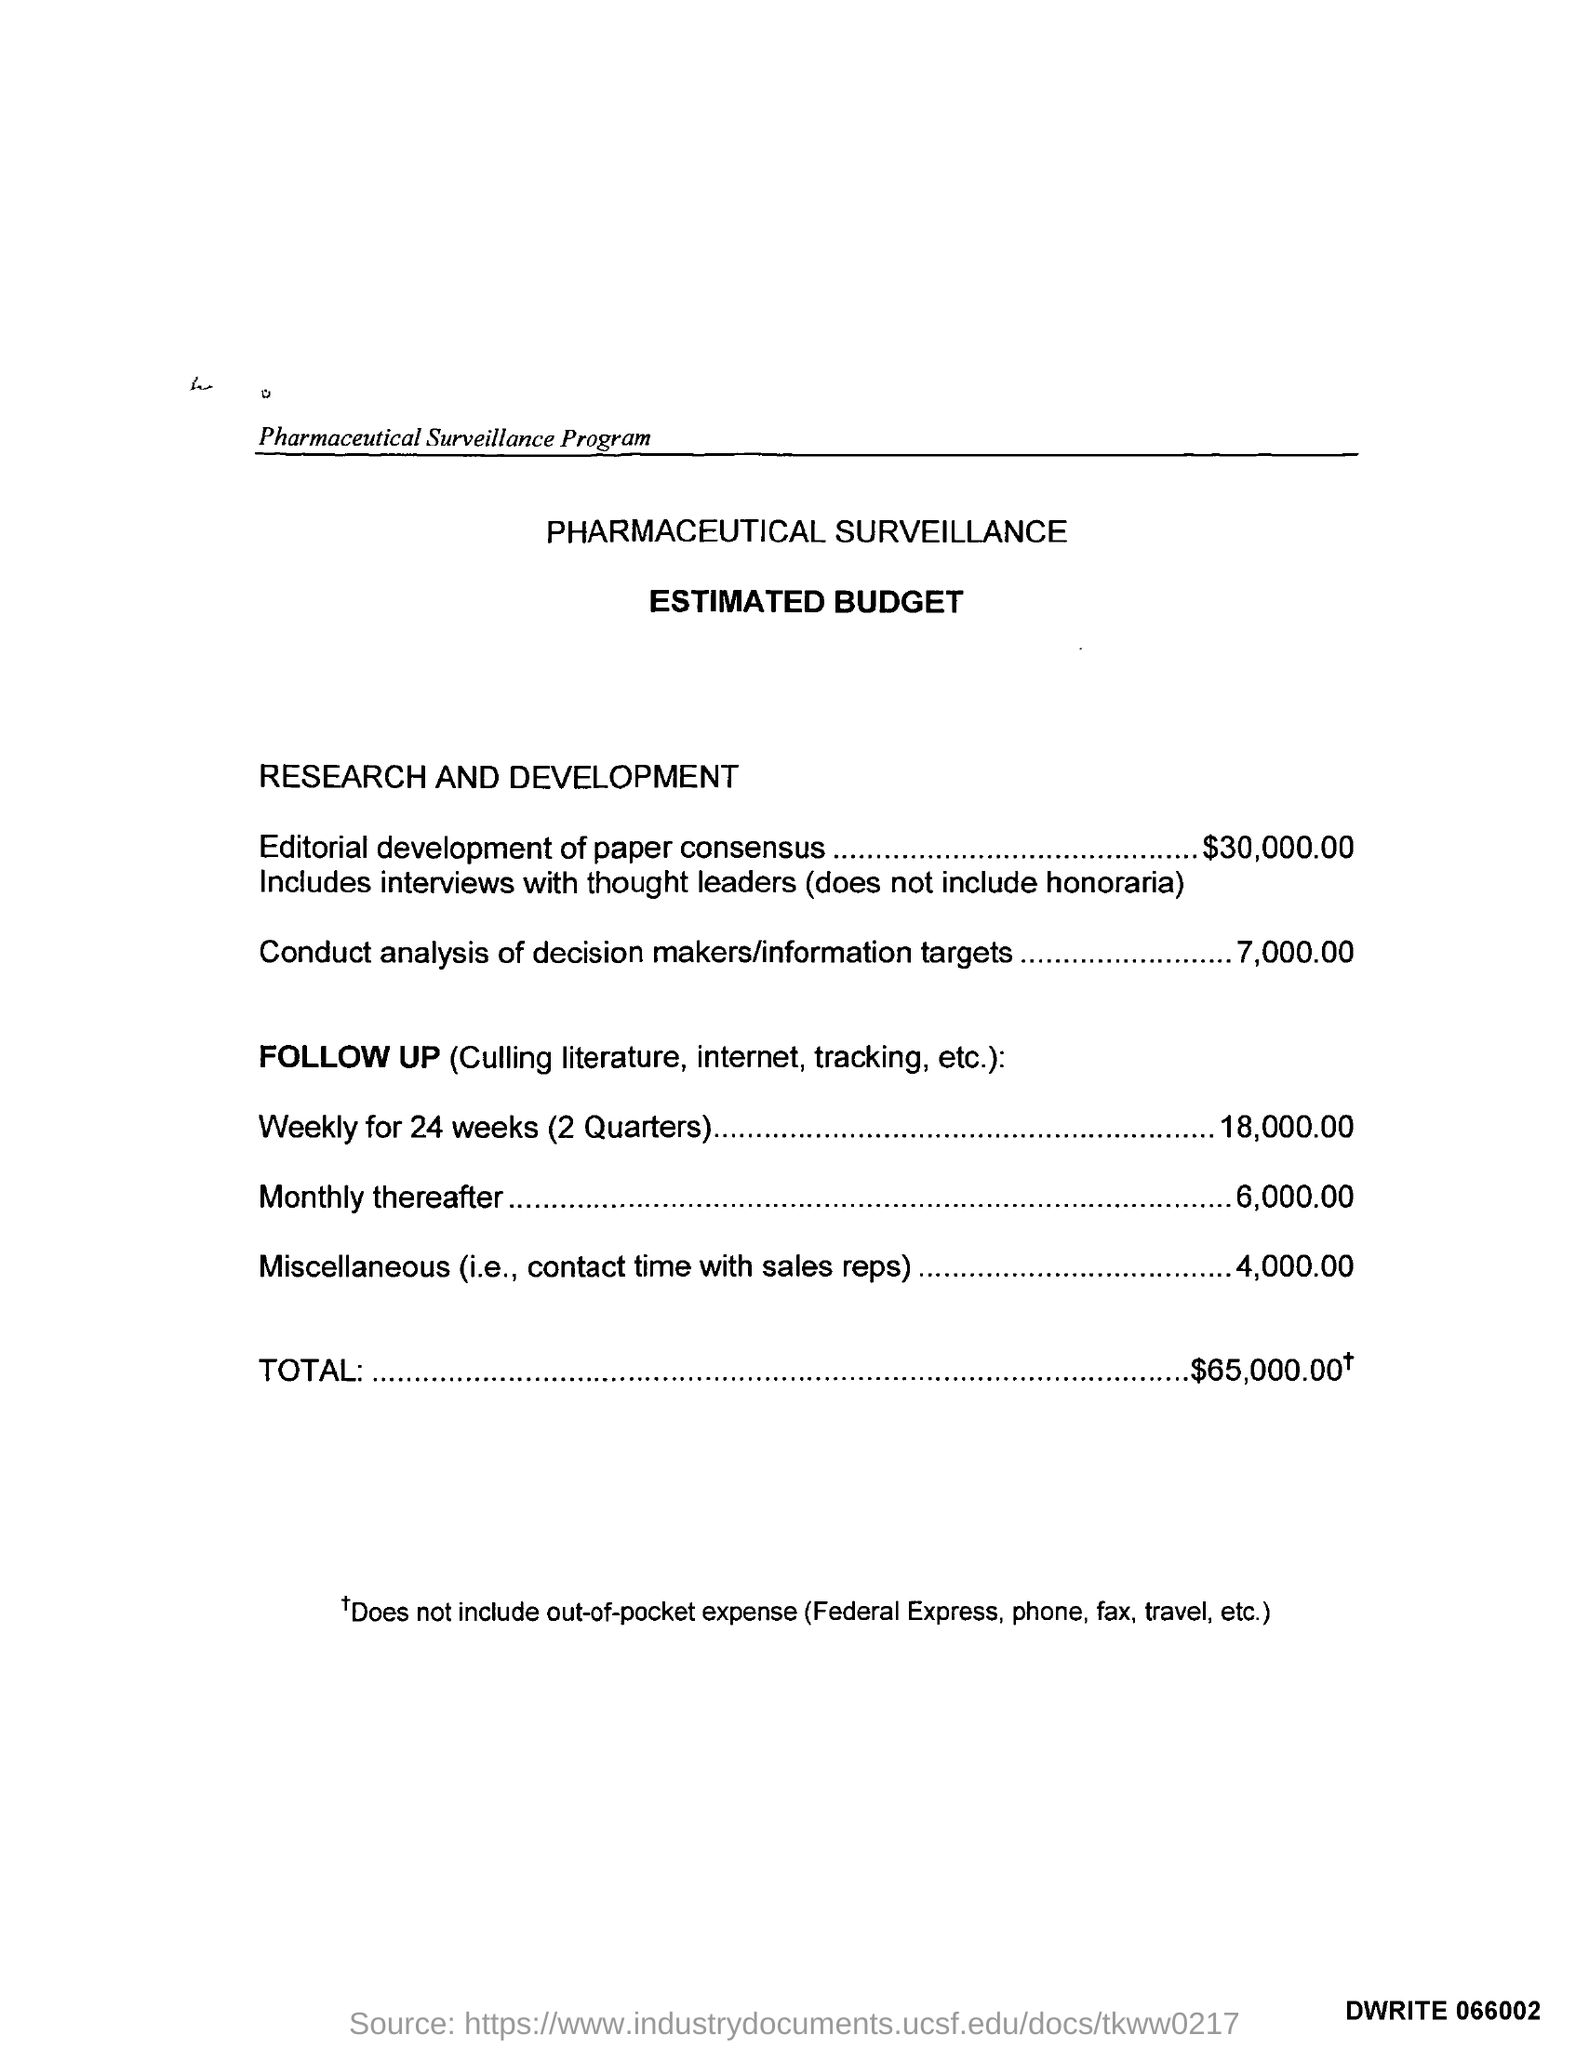Can you breakdown the total budget mentioned for pharmaceutical surveillance? Certainly! The total estimated budget for the pharmaceutical surveillance program is $65,000. It includes various components such as editorial development of paper consensus at $30,000, which involves interviews with thought leaders; the mentioned analysis of decision makers/information targets at $7,000; follow-up activities costing $18,000 for 24 weeks and $6,000 for monthly tracking thereafter; and miscellaneous expenses at $4,000. 